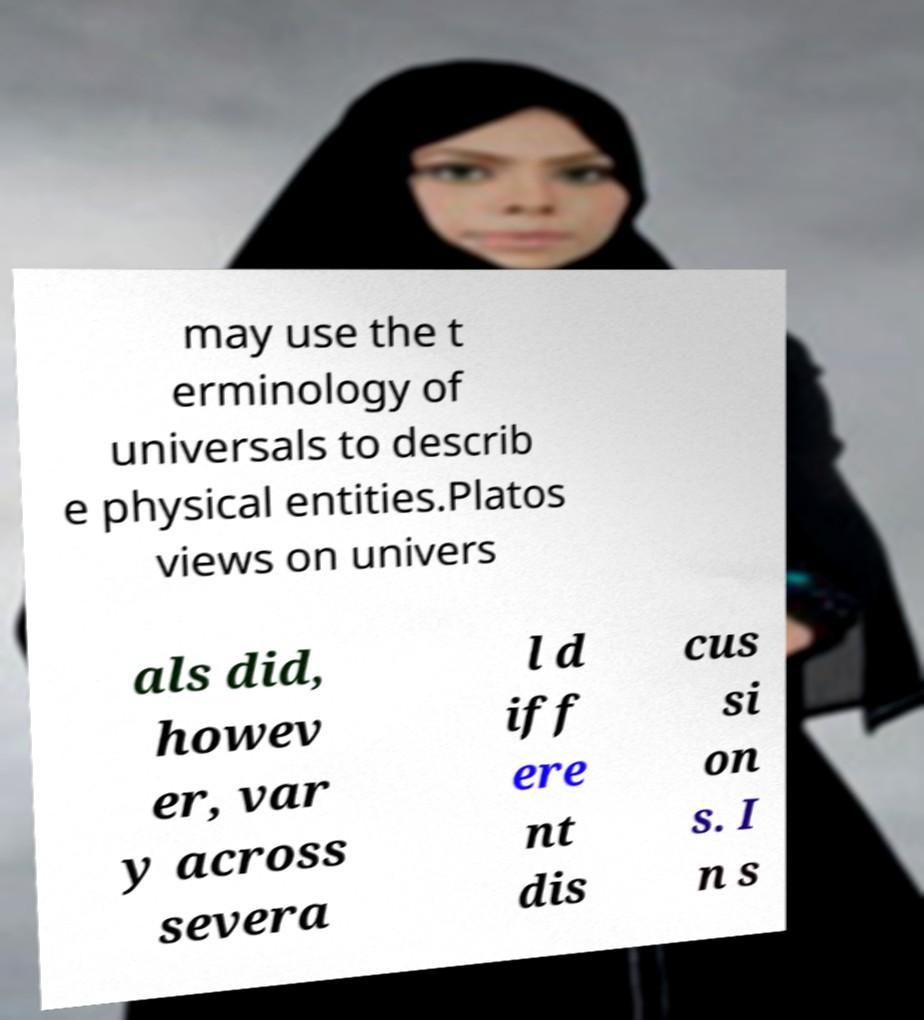For documentation purposes, I need the text within this image transcribed. Could you provide that? may use the t erminology of universals to describ e physical entities.Platos views on univers als did, howev er, var y across severa l d iff ere nt dis cus si on s. I n s 